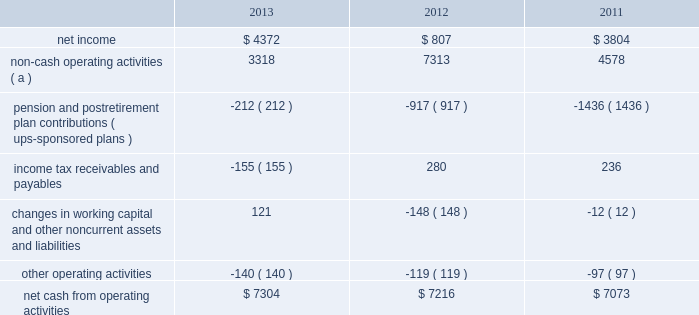United parcel service , inc .
And subsidiaries management's discussion and analysis of financial condition and results of operations liquidity and capital resources operating activities the following is a summary of the significant sources ( uses ) of cash from operating activities ( amounts in millions ) : .
( a ) represents depreciation and amortization , gains and losses on derivative and foreign exchange transactions , deferred income taxes , provisions for uncollectible accounts , pension and postretirement benefit expense , stock compensation expense , impairment charges and other non-cash items .
Cash from operating activities remained strong throughout the 2011 to 2013 time period .
Operating cash flow was favorably impacted in 2013 , compared with 2012 , by lower contributions into our defined benefit pension and postretirement benefit plans ; however , this was partially offset by certain tnt express transaction-related charges , as well as changes in income tax receivables and payables .
We paid a termination fee to tnt express of 20ac200 million ( $ 268 million ) under the agreement to terminate the merger protocol in the first quarter of 2013 .
Additionally , the cash payments for income taxes increased in 2013 compared with 2012 , and were impacted by the timing of current tax deductions .
Except for discretionary or accelerated fundings of our plans , contributions to our company-sponsored pension plans have largely varied based on whether any minimum funding requirements are present for individual pension plans .
2022 in 2013 , we did not have any required , nor make any discretionary , contributions to our primary company-sponsored pension plans in the u.s .
2022 in 2012 , we made a $ 355 million required contribution to the ups ibt pension plan .
2022 in 2011 , we made a $ 1.2 billion contribution to the ups ibt pension plan , which satisfied our 2011 contribution requirements and also approximately $ 440 million in contributions that would not have been required until after 2011 .
2022 the remaining contributions in the 2011 through 2013 period were largely due to contributions to our international pension plans and u.s .
Postretirement medical benefit plans .
As discussed further in the 201ccontractual commitments 201d section , we have minimum funding requirements in the next several years , primarily related to the ups ibt pension , ups retirement and ups pension plans .
As of december 31 , 2013 , the total of our worldwide holdings of cash and cash equivalents was $ 4.665 billion .
Approximately 45%-55% ( 45%-55 % ) of cash and cash equivalents was held by foreign subsidiaries throughout the year .
The amount of cash held by our u.s .
And foreign subsidiaries fluctuates throughout the year due to a variety of factors , including the timing of cash receipts and disbursements in the normal course of business .
Cash provided by operating activities in the united states continues to be our primary source of funds to finance domestic operating needs , capital expenditures , share repurchases and dividend payments to shareowners .
To the extent that such amounts represent previously untaxed earnings , the cash held by foreign subsidiaries would be subject to tax if such amounts were repatriated in the form of dividends ; however , not all international cash balances would have to be repatriated in the form of a dividend if returned to the u.s .
When amounts earned by foreign subsidiaries are expected to be indefinitely reinvested , no accrual for taxes is provided. .
What percentage of net cash from operating activities was derived from non-cash operating activities in 2013? 
Computations: (3318 / 7304)
Answer: 0.45427. 